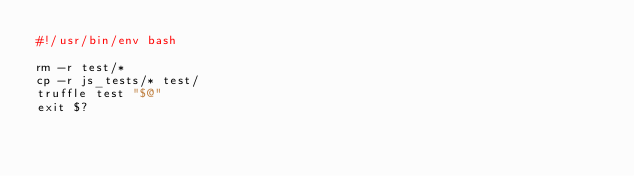<code> <loc_0><loc_0><loc_500><loc_500><_Bash_>#!/usr/bin/env bash

rm -r test/*
cp -r js_tests/* test/
truffle test "$@"
exit $?
</code> 